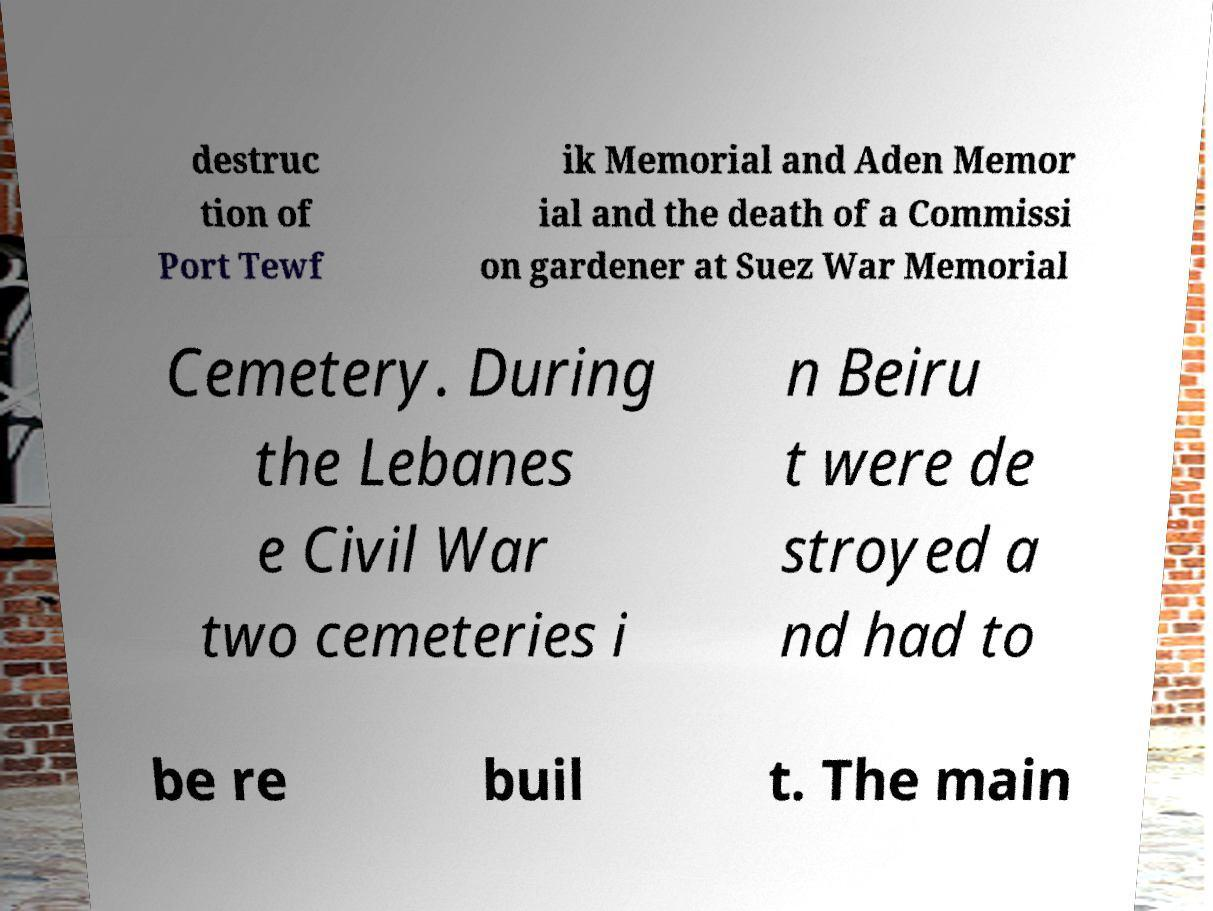Can you accurately transcribe the text from the provided image for me? destruc tion of Port Tewf ik Memorial and Aden Memor ial and the death of a Commissi on gardener at Suez War Memorial Cemetery. During the Lebanes e Civil War two cemeteries i n Beiru t were de stroyed a nd had to be re buil t. The main 